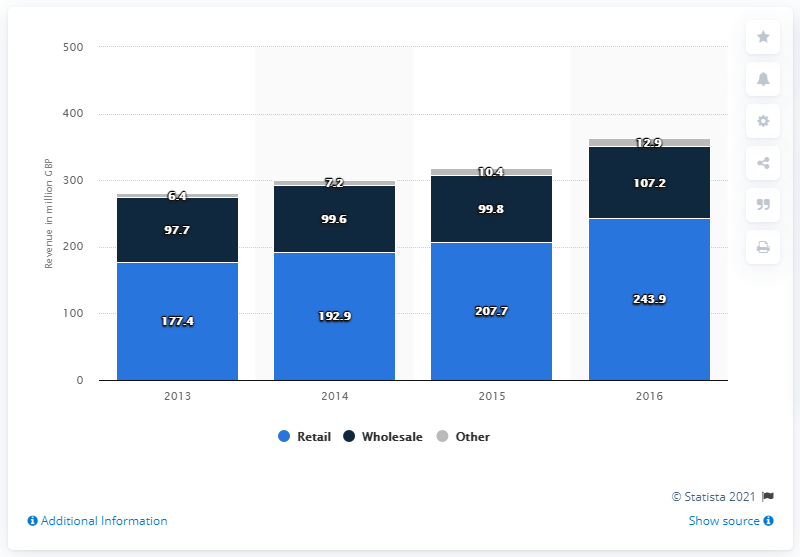List a handful of essential elements in this visual. In 2014, Jimmy Choo generated £192.9 million in revenue. In 2014, Jimmy Choo generated 99.6 million US dollars through wholesale sales. 